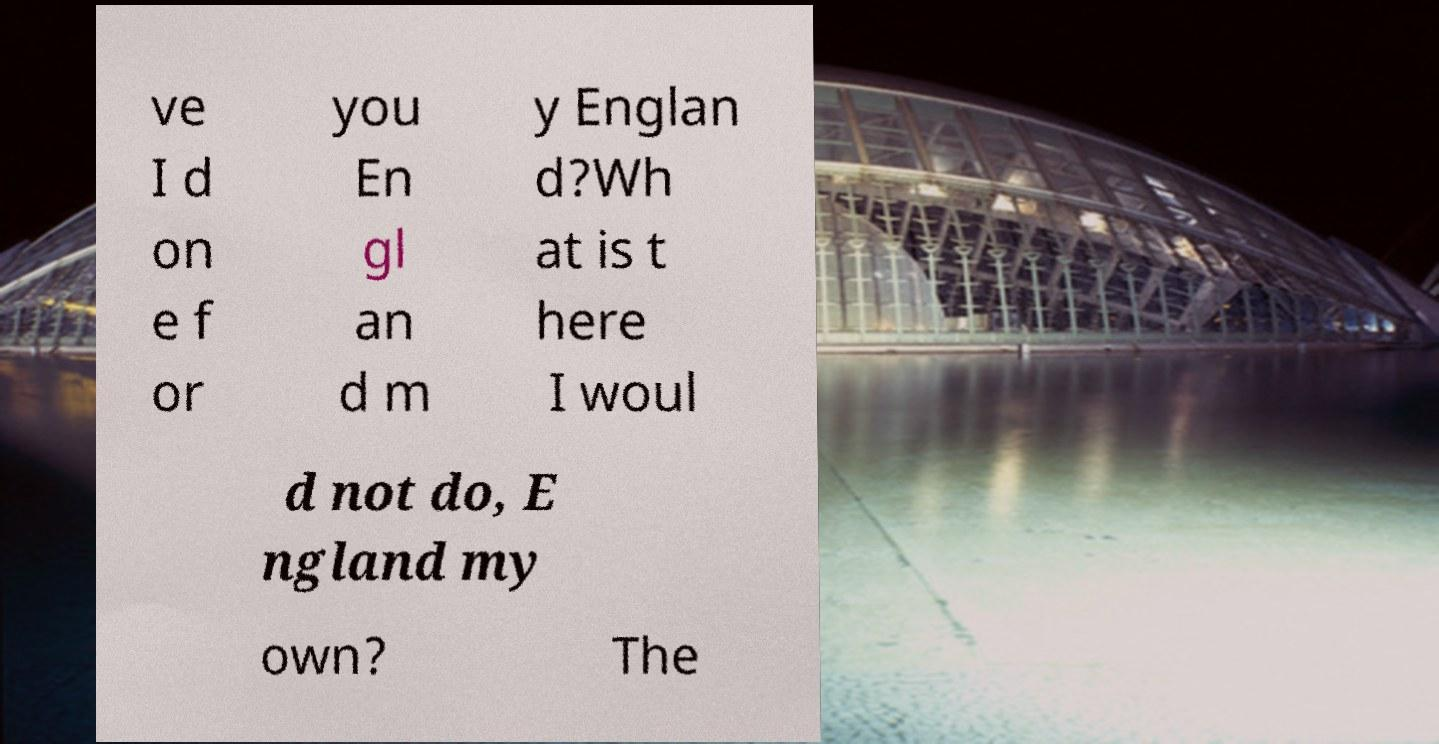Please read and relay the text visible in this image. What does it say? ve I d on e f or you En gl an d m y Englan d?Wh at is t here I woul d not do, E ngland my own? The 